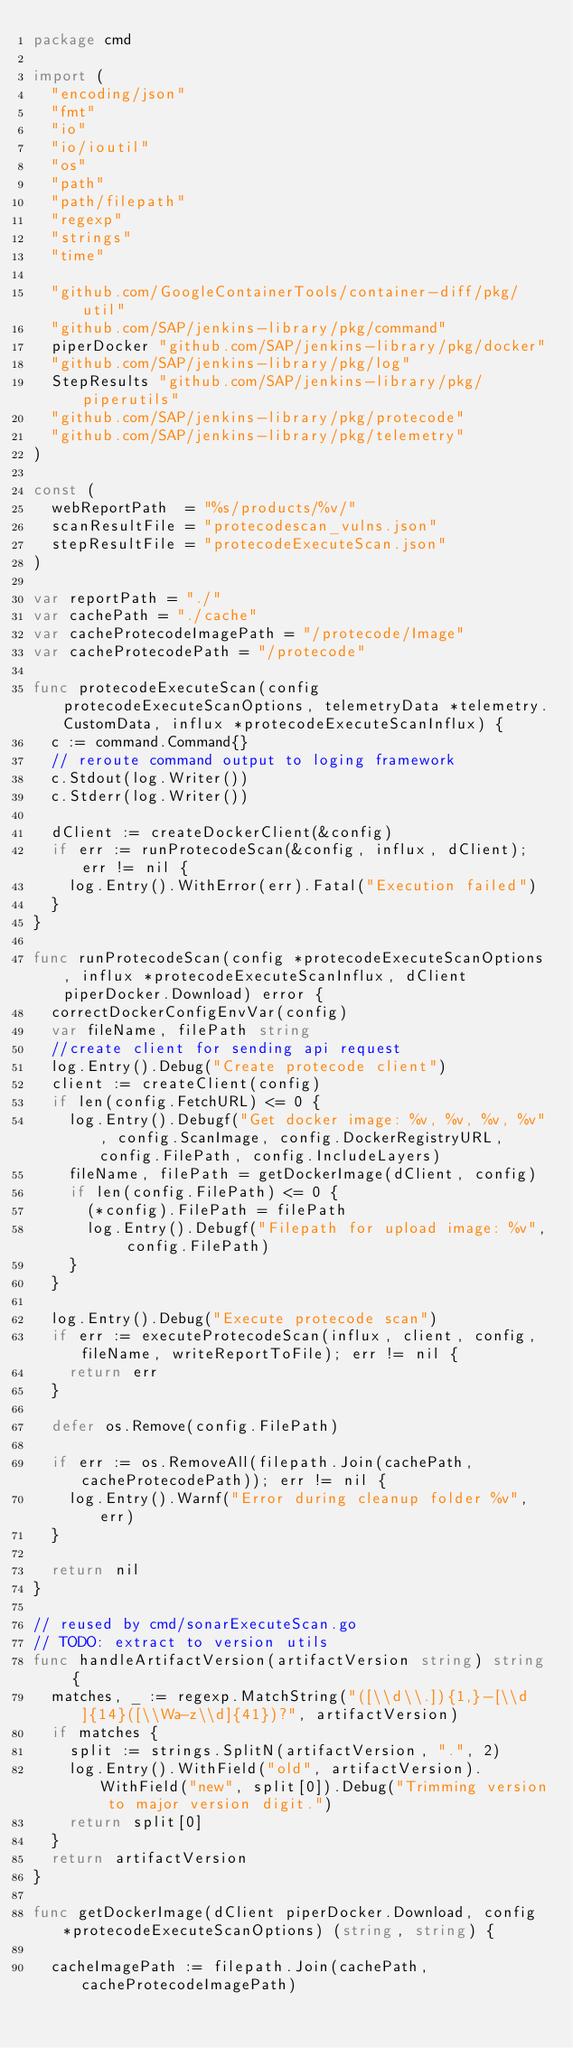Convert code to text. <code><loc_0><loc_0><loc_500><loc_500><_Go_>package cmd

import (
	"encoding/json"
	"fmt"
	"io"
	"io/ioutil"
	"os"
	"path"
	"path/filepath"
	"regexp"
	"strings"
	"time"

	"github.com/GoogleContainerTools/container-diff/pkg/util"
	"github.com/SAP/jenkins-library/pkg/command"
	piperDocker "github.com/SAP/jenkins-library/pkg/docker"
	"github.com/SAP/jenkins-library/pkg/log"
	StepResults "github.com/SAP/jenkins-library/pkg/piperutils"
	"github.com/SAP/jenkins-library/pkg/protecode"
	"github.com/SAP/jenkins-library/pkg/telemetry"
)

const (
	webReportPath  = "%s/products/%v/"
	scanResultFile = "protecodescan_vulns.json"
	stepResultFile = "protecodeExecuteScan.json"
)

var reportPath = "./"
var cachePath = "./cache"
var cacheProtecodeImagePath = "/protecode/Image"
var cacheProtecodePath = "/protecode"

func protecodeExecuteScan(config protecodeExecuteScanOptions, telemetryData *telemetry.CustomData, influx *protecodeExecuteScanInflux) {
	c := command.Command{}
	// reroute command output to loging framework
	c.Stdout(log.Writer())
	c.Stderr(log.Writer())

	dClient := createDockerClient(&config)
	if err := runProtecodeScan(&config, influx, dClient); err != nil {
		log.Entry().WithError(err).Fatal("Execution failed")
	}
}

func runProtecodeScan(config *protecodeExecuteScanOptions, influx *protecodeExecuteScanInflux, dClient piperDocker.Download) error {
	correctDockerConfigEnvVar(config)
	var fileName, filePath string
	//create client for sending api request
	log.Entry().Debug("Create protecode client")
	client := createClient(config)
	if len(config.FetchURL) <= 0 {
		log.Entry().Debugf("Get docker image: %v, %v, %v, %v", config.ScanImage, config.DockerRegistryURL, config.FilePath, config.IncludeLayers)
		fileName, filePath = getDockerImage(dClient, config)
		if len(config.FilePath) <= 0 {
			(*config).FilePath = filePath
			log.Entry().Debugf("Filepath for upload image: %v", config.FilePath)
		}
	}

	log.Entry().Debug("Execute protecode scan")
	if err := executeProtecodeScan(influx, client, config, fileName, writeReportToFile); err != nil {
		return err
	}

	defer os.Remove(config.FilePath)

	if err := os.RemoveAll(filepath.Join(cachePath, cacheProtecodePath)); err != nil {
		log.Entry().Warnf("Error during cleanup folder %v", err)
	}

	return nil
}

// reused by cmd/sonarExecuteScan.go
// TODO: extract to version utils
func handleArtifactVersion(artifactVersion string) string {
	matches, _ := regexp.MatchString("([\\d\\.]){1,}-[\\d]{14}([\\Wa-z\\d]{41})?", artifactVersion)
	if matches {
		split := strings.SplitN(artifactVersion, ".", 2)
		log.Entry().WithField("old", artifactVersion).WithField("new", split[0]).Debug("Trimming version to major version digit.")
		return split[0]
	}
	return artifactVersion
}

func getDockerImage(dClient piperDocker.Download, config *protecodeExecuteScanOptions) (string, string) {

	cacheImagePath := filepath.Join(cachePath, cacheProtecodeImagePath)</code> 